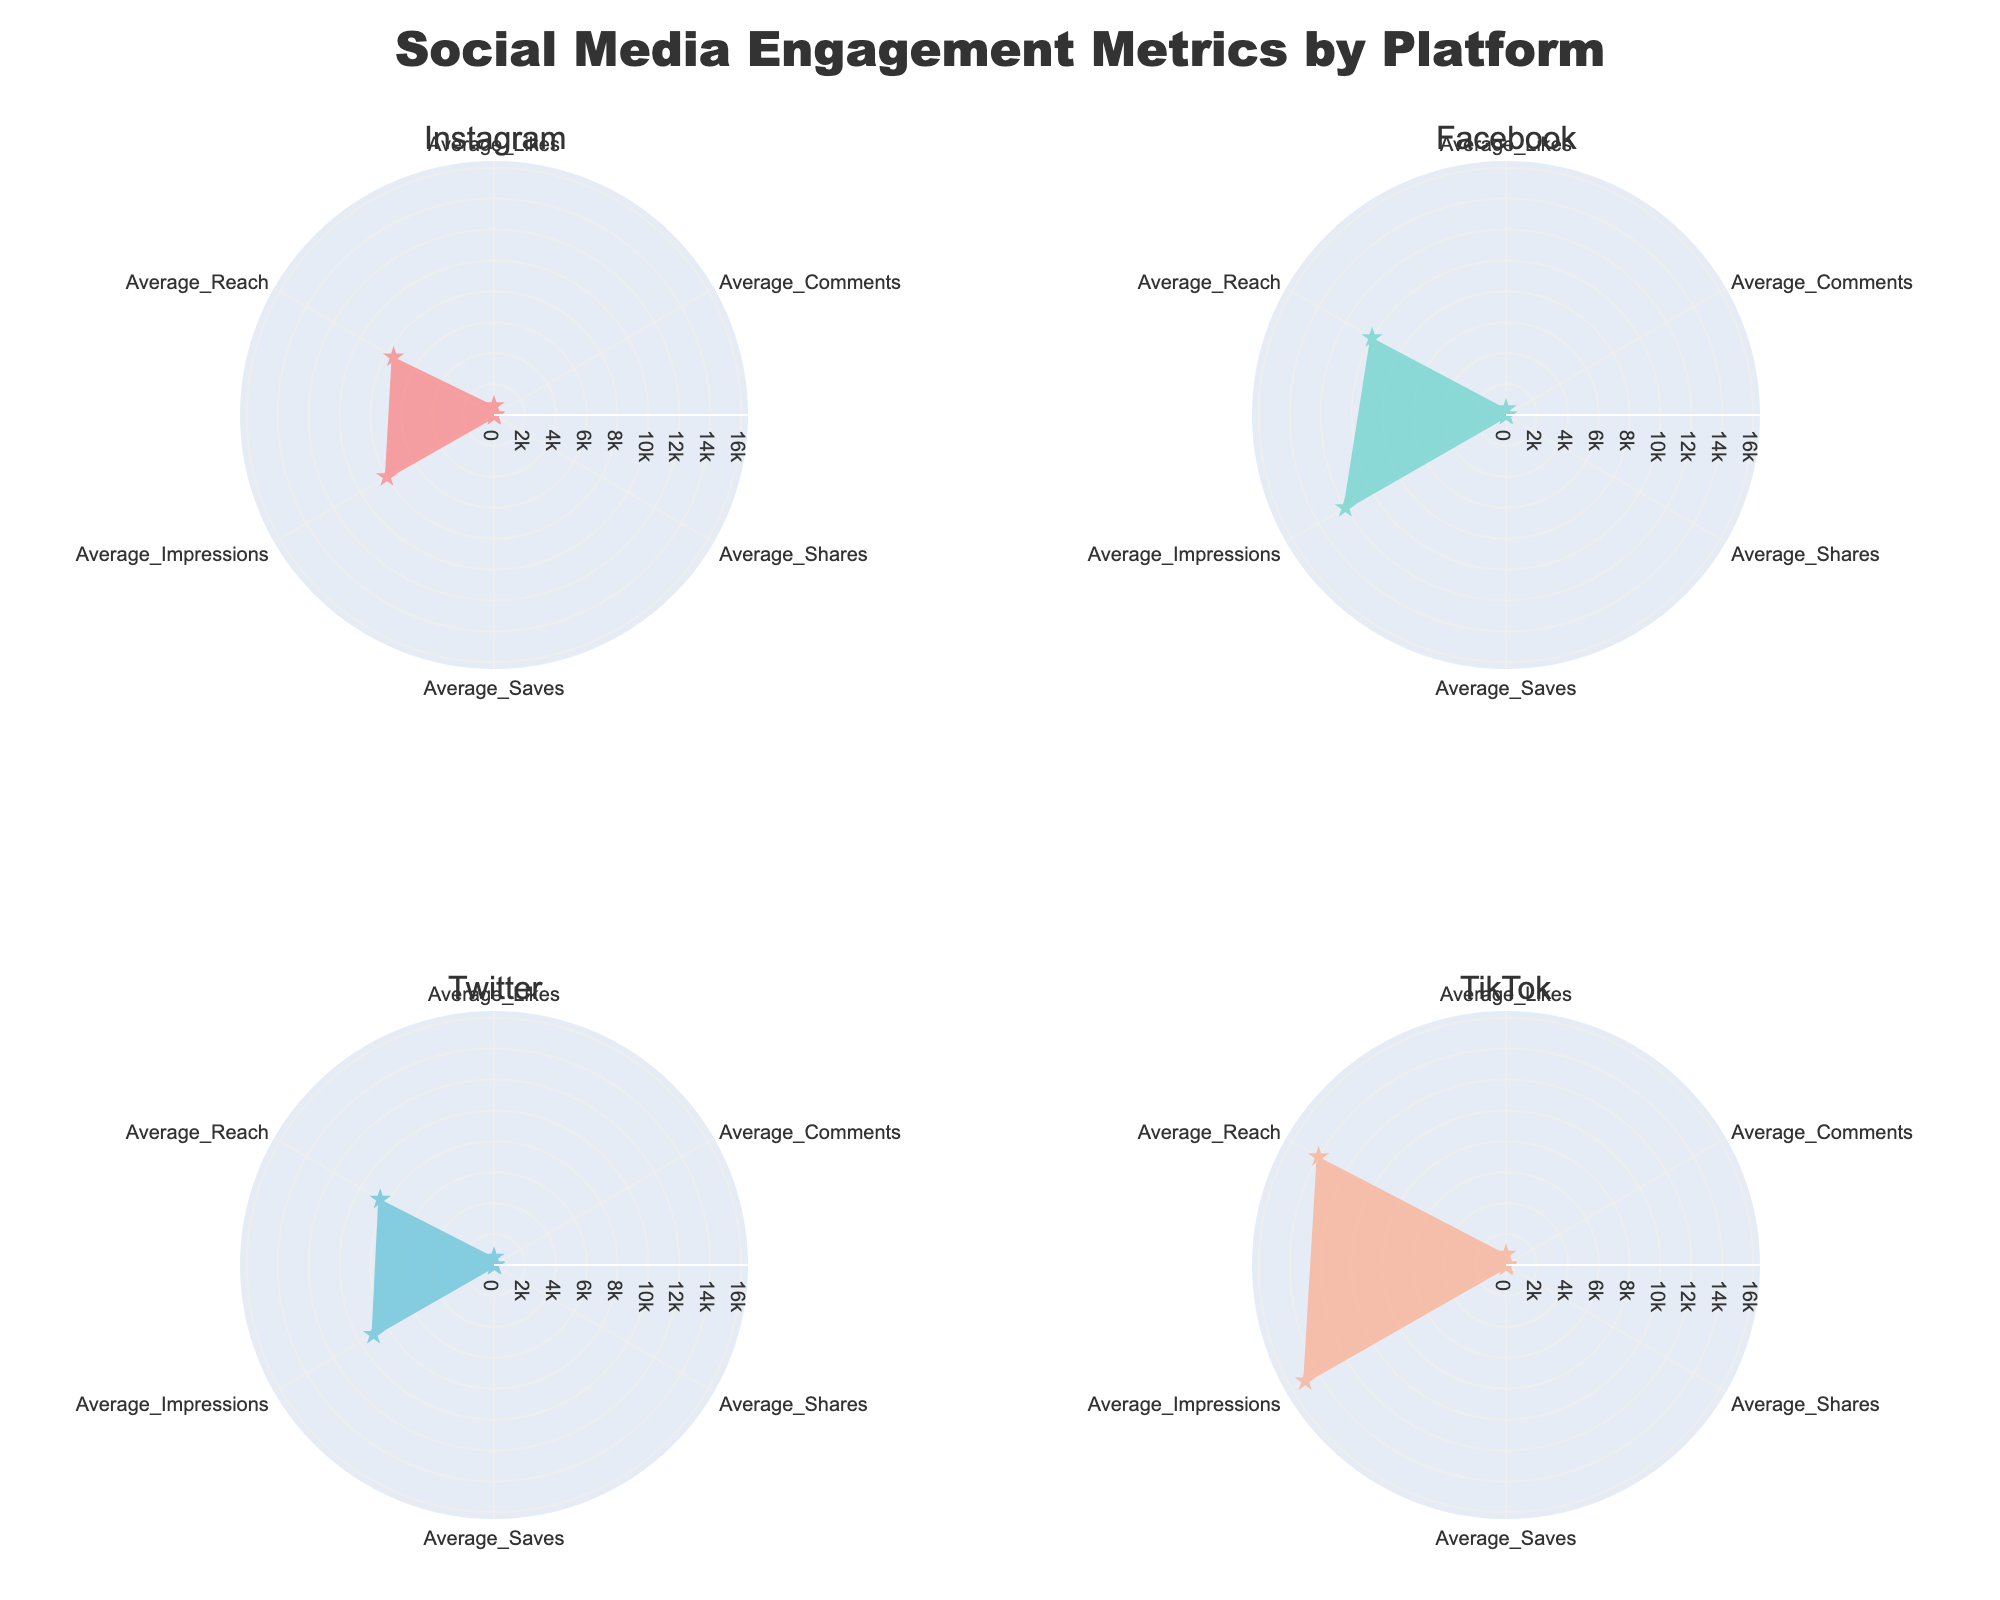Which platform has the highest average likes? Observing the figure, we compare the average likes for all platforms. TikTok is the platform with the highest average likes at 700.
Answer: TikTok What is the difference between average reach on Facebook and Twitter? Facebook has an average reach of 10,000, while Twitter has 8,500. The difference between them is 10,000 - 8,500 = 1,500.
Answer: 1,500 Which platform has the most balanced engagement across all metrics, and why? We must observe the radar chart plot areas for each platform. The platform with the most balanced and uniform shape around the center indicates balanced engagement. Based on the visual uniformity of the shapes' radii, Instagram appears to have the most balanced engagement among the metrics.
Answer: Instagram How does TikTok's audience demographic compare to Twitter's? TikTok's audience is predominantly 18-24 years old (60%), with decreasing percentages for older age groups. Twitter's largest audience segment is also 18-24 years old (40%), but the distribution is more spread out among the other age groups compared to TikTok. TikTok has a significantly higher proportion of younger users compared to Twitter.
Answer: TikTok has a younger audience Which metric shows the least variation among different platforms? Analyzing the radar chart, we see that the metric with the least variation in values across different platforms is Average Comments. The values are close to each other for all platforms: Instagram (40), Facebook (35), Twitter (50), and TikTok (45).
Answer: Average Comments 